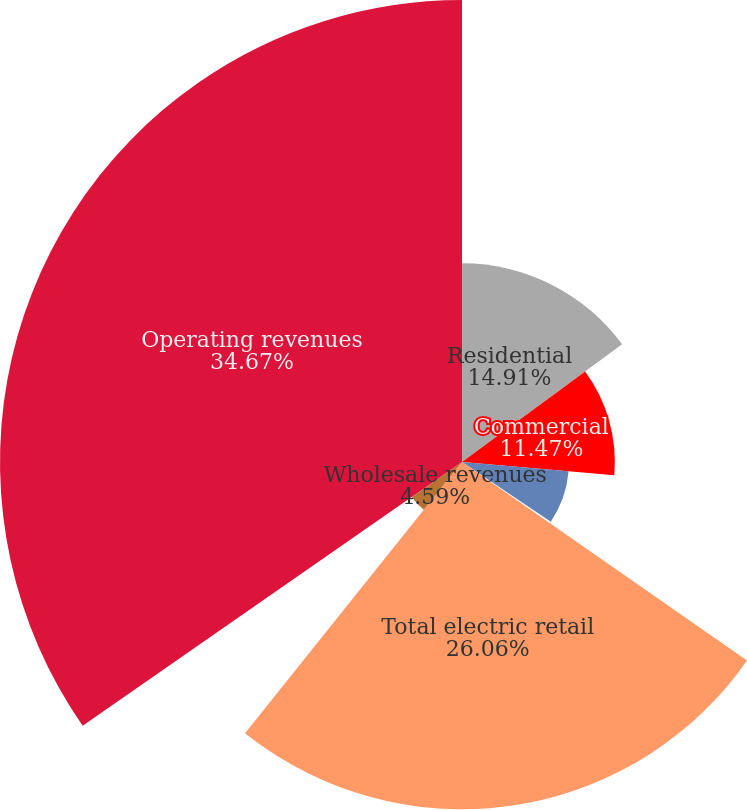Convert chart. <chart><loc_0><loc_0><loc_500><loc_500><pie_chart><fcel>Residential<fcel>Commercial<fcel>Industrial<fcel>Other retail revenues<fcel>Total electric retail<fcel>Wholesale revenues<fcel>Operating revenues<nl><fcel>14.91%<fcel>11.47%<fcel>8.03%<fcel>0.27%<fcel>26.06%<fcel>4.59%<fcel>34.67%<nl></chart> 